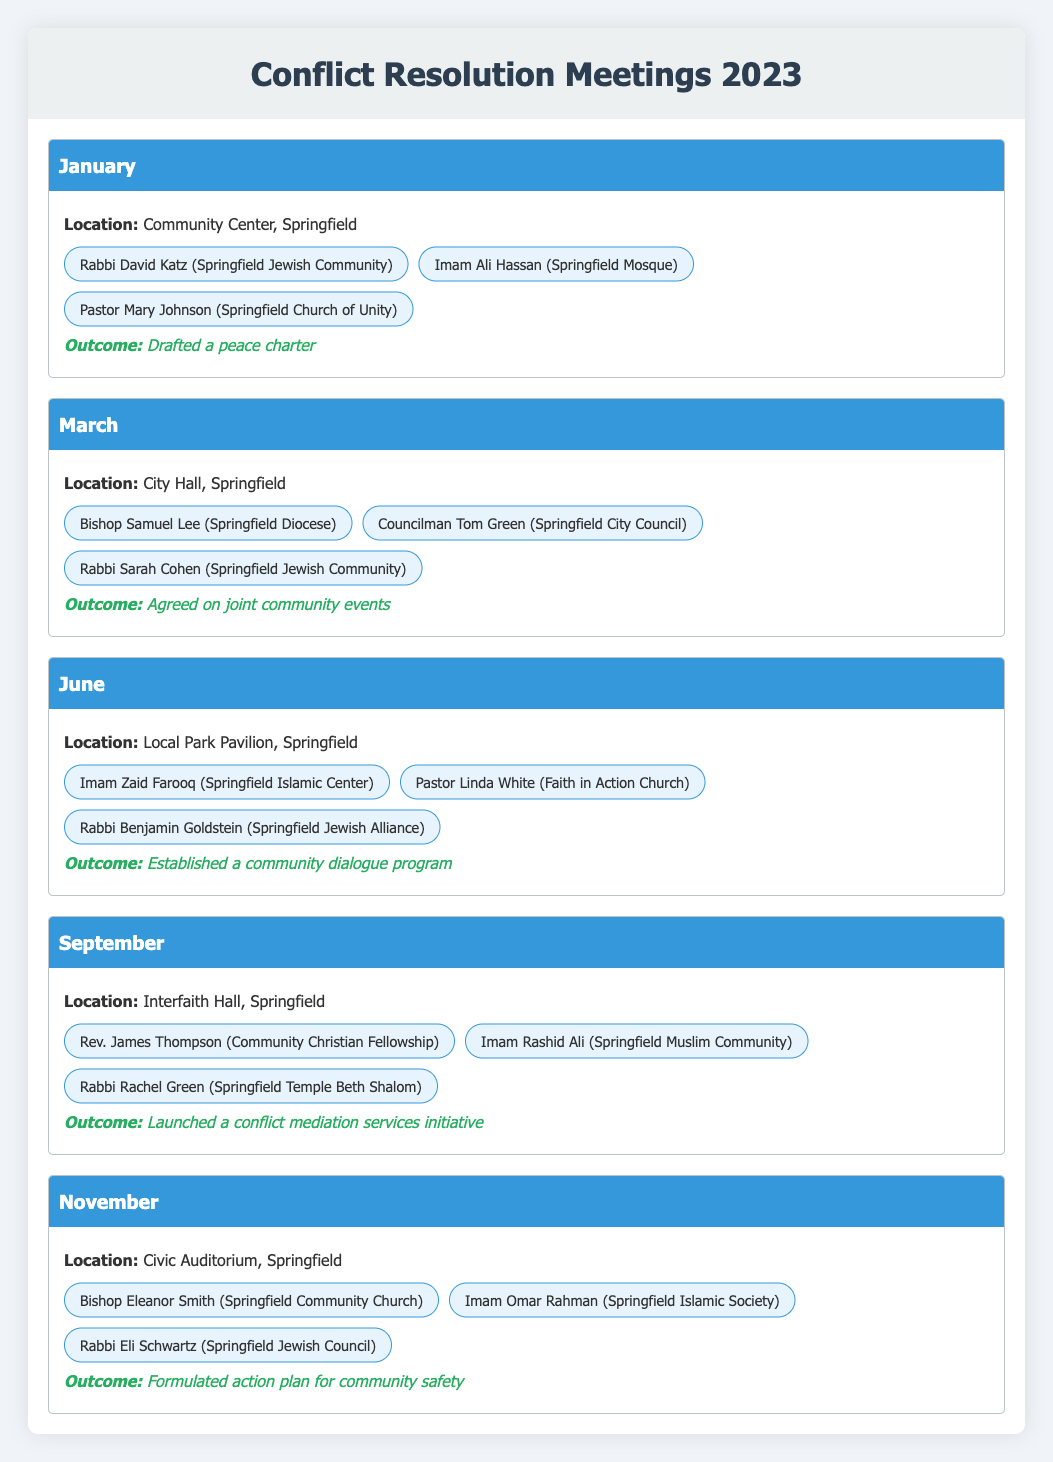What was the outcome of the meeting held in January? The table shows that the outcome of the January meeting was the drafting of a peace charter.
Answer: Drafted a peace charter How many meetings were held in total in 2023? By counting the individual months listed, we see that there are five meetings: January, March, June, September, and November.
Answer: 5 Did any meeting take place in February? The table lists meetings for January, March, June, September, and November, but does not mention February.
Answer: No Which organizations were represented in the June meeting? Referring to the June section of the table, the organizations listed are Springfield Islamic Center, Faith in Action Church, and Springfield Jewish Alliance.
Answer: Springfield Islamic Center, Faith in Action Church, Springfield Jewish Alliance What was the meeting outcome for September? From the table, we find that the outcome for the September meeting was the launch of a conflict mediation services initiative.
Answer: Launched a conflict mediation services initiative How many different religious leaders participated across all meetings? By listing each participant in each months' meeting without repetition, we find the unique individuals are Rabbi David Katz, Imam Ali Hassan, Pastor Mary Johnson, Bishop Samuel Lee, Councilman Tom Green, Rabbi Sarah Cohen, Imam Zaid Farooq, Pastor Linda White, Rabbi Benjamin Goldstein, Rev. James Thompson, Imam Rashid Ali, Rabbi Rachel Green, Bishop Eleanor Smith, Imam Omar Rahman, and Rabbi Eli Schwartz, totaling 15 unique leaders.
Answer: 15 Which month had the largest number of participants in its meeting? Each meeting listed has three participants. Since all meetings have the same number of participants, we conclude there is no month with a larger number of participants.
Answer: None; all have three participants What was the location of the meeting that led to the formulation of an action plan for community safety? The table indicates that the meeting which resulted in the formulation of the action plan for community safety took place in the Civic Auditorium, Springfield in November.
Answer: Civic Auditorium, Springfield Which two months had similarly focused outcomes of establishing community initiatives? The June meeting established a community dialogue program, and the September meeting launched a conflict mediation services initiative. Both are initiatives aimed at community engagement and support.
Answer: June and September 